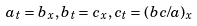<formula> <loc_0><loc_0><loc_500><loc_500>a _ { t } = b _ { x } , b _ { t } = c _ { x } , c _ { t } = ( b c / a ) _ { x }</formula> 